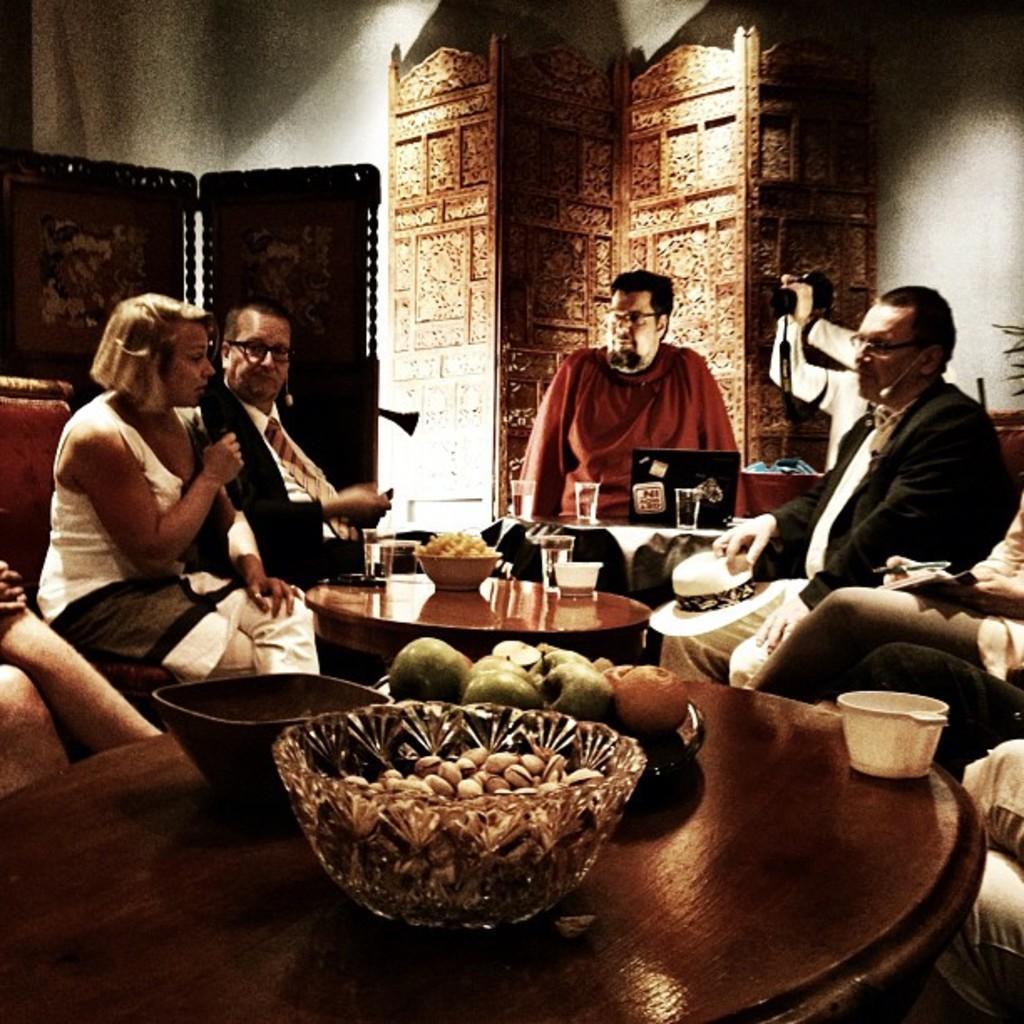Describe this image in one or two sentences. The image is inside the room. In the image there are group of people on left side there is a woman who is holding her microphone and opened her mouth for talking. In middle of the image there is a man who is sitting in front of a laptop which is placed on table. On table we can see a glass,bowl with some food,fruits,mug. On right side there is a man who is holding his hat and there is also a another man who is holding his pen. In background there is a wall which is in white color. 